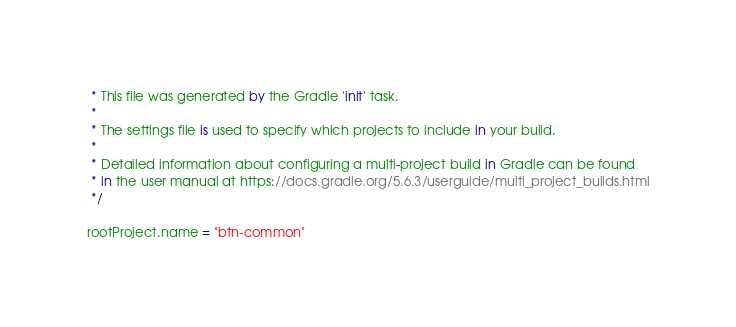Convert code to text. <code><loc_0><loc_0><loc_500><loc_500><_Kotlin_> * This file was generated by the Gradle 'init' task.
 *
 * The settings file is used to specify which projects to include in your build.
 *
 * Detailed information about configuring a multi-project build in Gradle can be found
 * in the user manual at https://docs.gradle.org/5.6.3/userguide/multi_project_builds.html
 */

rootProject.name = "btn-common"
</code> 